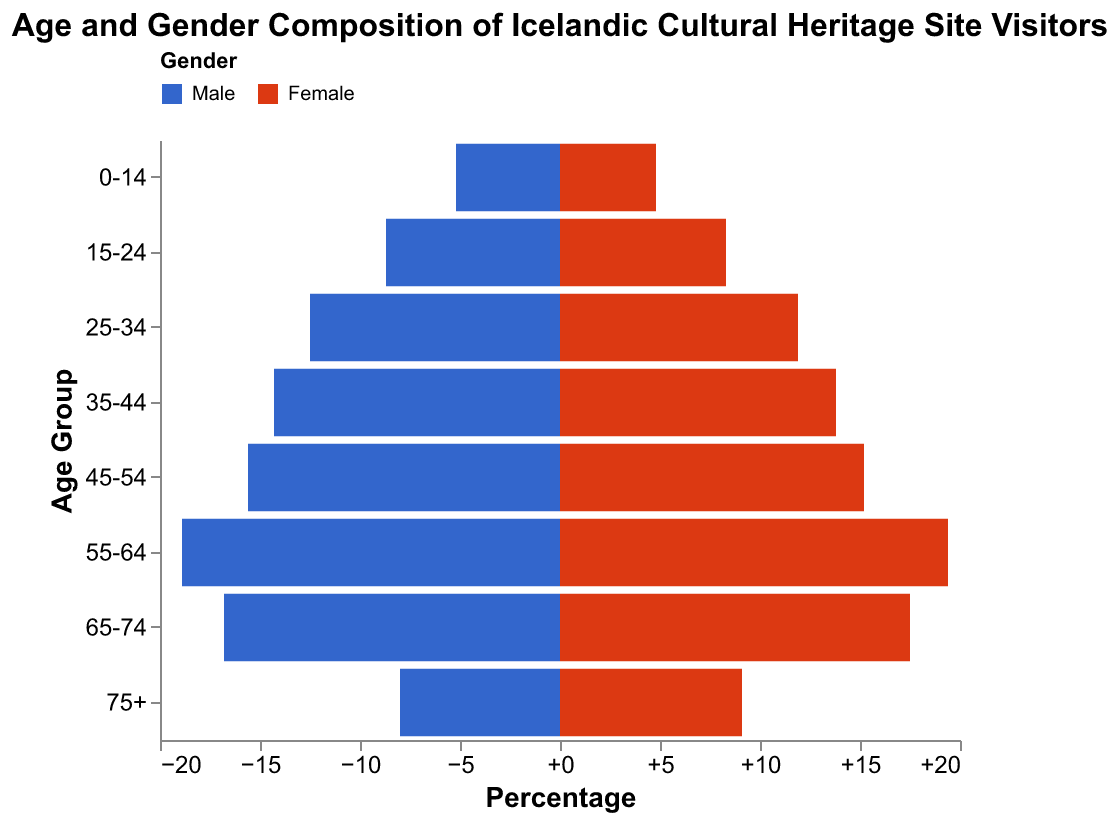Which age group has the highest percentage of male visitors? To identify the age group with the highest percentage of male visitors, we compare the values for the "Male" gender across all age groups from the figure. The age group "55-64" has the highest percentage at 18.9%.
Answer: 55-64 Which age group has the lowest percentage of female visitors? To find the age group with the lowest percentage of female visitors, examine the values for the "Female" gender across all age groups. The age group "0-14" has the lowest percentage at 4.8%.
Answer: 0-14 What is the combined percentage of visitors aged 65-74? To calculate the combined percentage for visitors aged 65-74, add the percentages of male and female visitors for that age group: 16.8% (male) + 17.5% (female) = 34.3%.
Answer: 34.3% How do the visitor percentages compare between males and females in the age group 25-34? To compare these percentages, look at the values for "Male" and "Female" in the age group "25-34". Males are at 12.5% and females are at 11.9%. Males are slightly higher by 0.6%.
Answer: Males are 0.6% higher Which gender has a higher percentage of visitors in the age group 75+? Compare the percentages of male and female visitors in the age group "75+." Females have a higher percentage at 9.1% compared to males at 8.0%.
Answer: Female What is the percentage difference between male and female visitors in the age group 35-44? To find the percentage difference, subtract the female percentage from the male percentage in the age group "35-44": 14.3% (male) - 13.8% (female) = 0.5%.
Answer: 0.5% What percentage of visitors are in the age group 15-24 across both genders? Add the male and female percentages for the age group "15-24": 8.7% (male) + 8.3% (female) = 17%.
Answer: 17% Which gender and age group pair has the highest visitor percentage overall? Compare the percentages of all gender and age group pairs. The age group "55-64" for females has the highest percentage at 19.4%.
Answer: Female aged 55-64 